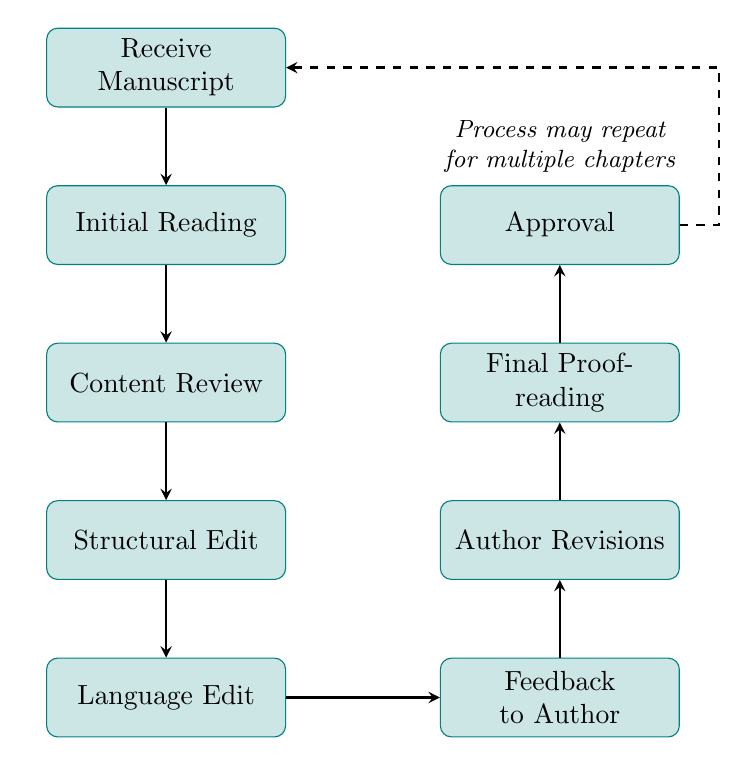What is the first step in the editing process? The first step is labeled as "Receive Manuscript," which indicates that the editing process begins by obtaining the chapter draft from the retired surgeon.
Answer: Receive Manuscript How many total nodes are in the flow chart? By counting the individual processes listed in the diagram, we can see that there are a total of eight distinct steps that make up the editing process.
Answer: Eight What happens after "Language Edit"? According to the flow of the diagram, after the "Language Edit," the next step is "Feedback to Author," which shows that feedback is provided to the author after editing the language.
Answer: Feedback to Author Which step involves correcting errors? The step that involves correcting errors is "Language Edit," where grammar, punctuation, and spelling mistakes are addressed and improved.
Answer: Language Edit What is the last step in the editing process? The last step is named "Approval," which signifies that the process concludes with obtaining the retired surgeon’s final approval on the edited chapter.
Answer: Approval How does the process continue after reaching "Approval"? After "Approval," the diagram indicates that the process may repeat for multiple chapters, as shown by the dashed arrow returning to "Receive Manuscript."
Answer: Process may repeat for multiple chapters What type of editing is performed in the third step? The third step in the diagram is "Content Review," where the focus is on checking the accuracy of medical details and overall narrative coherence.
Answer: Content Review Which node is positioned to the right of "Language Edit"? The node positioned to the right of "Language Edit" is "Feedback to Author," indicating that feedback is given after language corrections are made.
Answer: Feedback to Author What does "Structural Edit" aim to improve? The "Structural Edit" aims to improve the organization of sections for better flow, clarity, and engagement in the narrative.
Answer: Flow, clarity, and engagement 